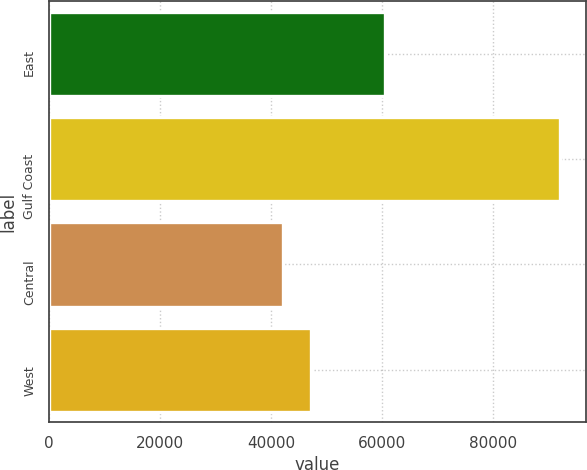<chart> <loc_0><loc_0><loc_500><loc_500><bar_chart><fcel>East<fcel>Gulf Coast<fcel>Central<fcel>West<nl><fcel>60494<fcel>92095<fcel>42182<fcel>47173.3<nl></chart> 